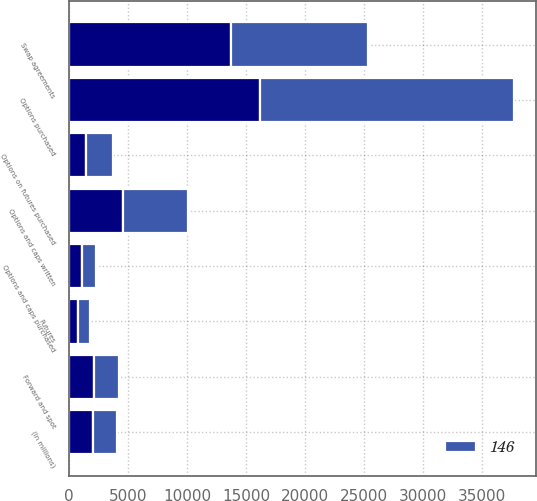Convert chart to OTSL. <chart><loc_0><loc_0><loc_500><loc_500><stacked_bar_chart><ecel><fcel>(In millions)<fcel>Swap agreements<fcel>Options and caps purchased<fcel>Options and caps written<fcel>Futures<fcel>Options on futures purchased<fcel>Forward and spot<fcel>Options purchased<nl><fcel>nan<fcel>2008<fcel>13718<fcel>1058<fcel>4590<fcel>779<fcel>1444<fcel>2126.5<fcel>16183<nl><fcel>146<fcel>2007<fcel>11637<fcel>1241<fcel>5519<fcel>957<fcel>2245<fcel>2126.5<fcel>21538<nl></chart> 